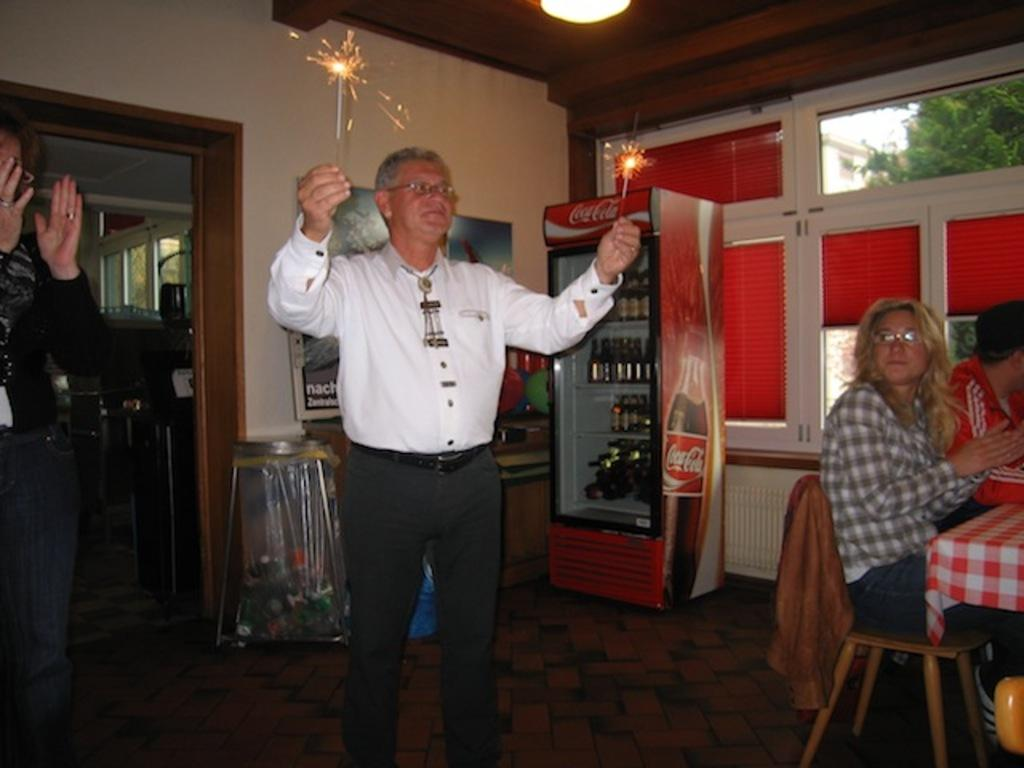What is the man in the image doing? The man is standing in the image and holding a cracker. What are the other men in the image doing? The other men in the image are sitting. What furniture is present in the image? There are chairs in the image. What can be seen in the background of the image? There are bottles, a window, and a wall visible in the background. What type of cable is being used by the maid in the image? There is no maid or cable present in the image. 